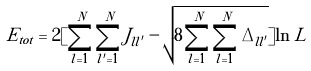<formula> <loc_0><loc_0><loc_500><loc_500>E _ { t o t } = 2 [ \sum _ { l = 1 } ^ { N } \sum _ { l ^ { \prime } = 1 } ^ { N } J _ { l l ^ { \prime } } - \sqrt { 8 \sum _ { l = 1 } ^ { N } \sum _ { l = 1 } ^ { N } \Delta _ { l l ^ { \prime } } } ] \ln L</formula> 